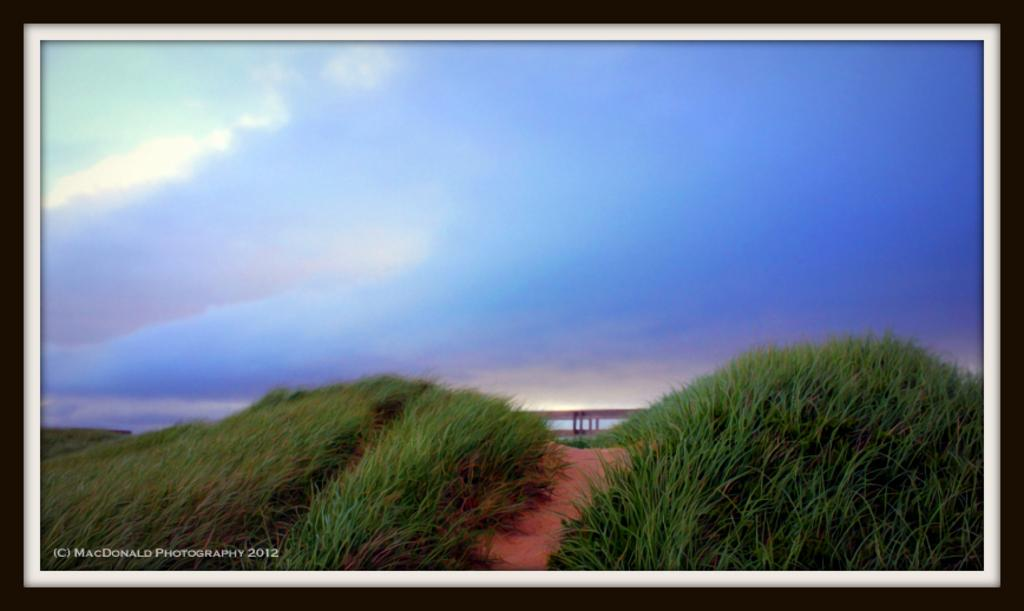What type of artwork is depicted in the image? The image appears to be a painting. What can be seen in the foreground of the painting? There are fields and a path in the foreground of the image. Is there any text present in the image? Yes, there is text in the foreground of the image. What is visible at the top of the image? The sky is visible at the top of the image. How are the borders of the image presented? The image has black and white borders. What type of rose can be seen growing in the fields in the image? There is no rose present in the image; the foreground features fields and a path. 